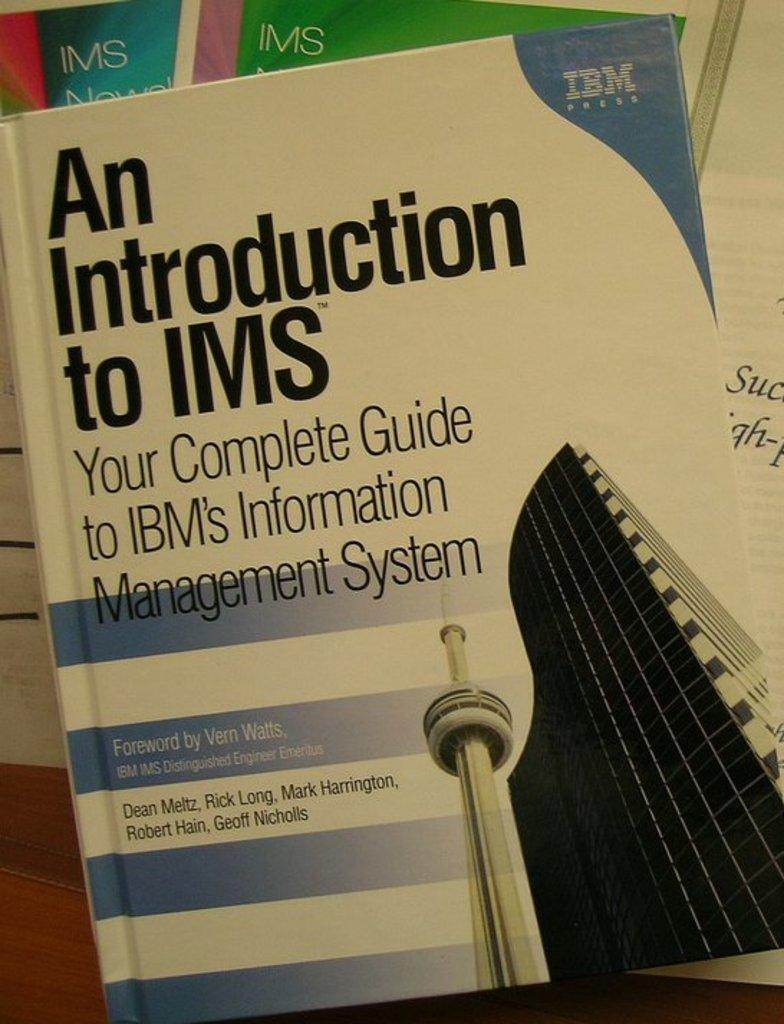<image>
Create a compact narrative representing the image presented. A book that was entitled "An Introduction to IMS - Your Complete Guide to IBM' Information Management System by Dean Meltz, Rick Long, Mark Harrington, Robert Hain and Geoff Nicholls. 